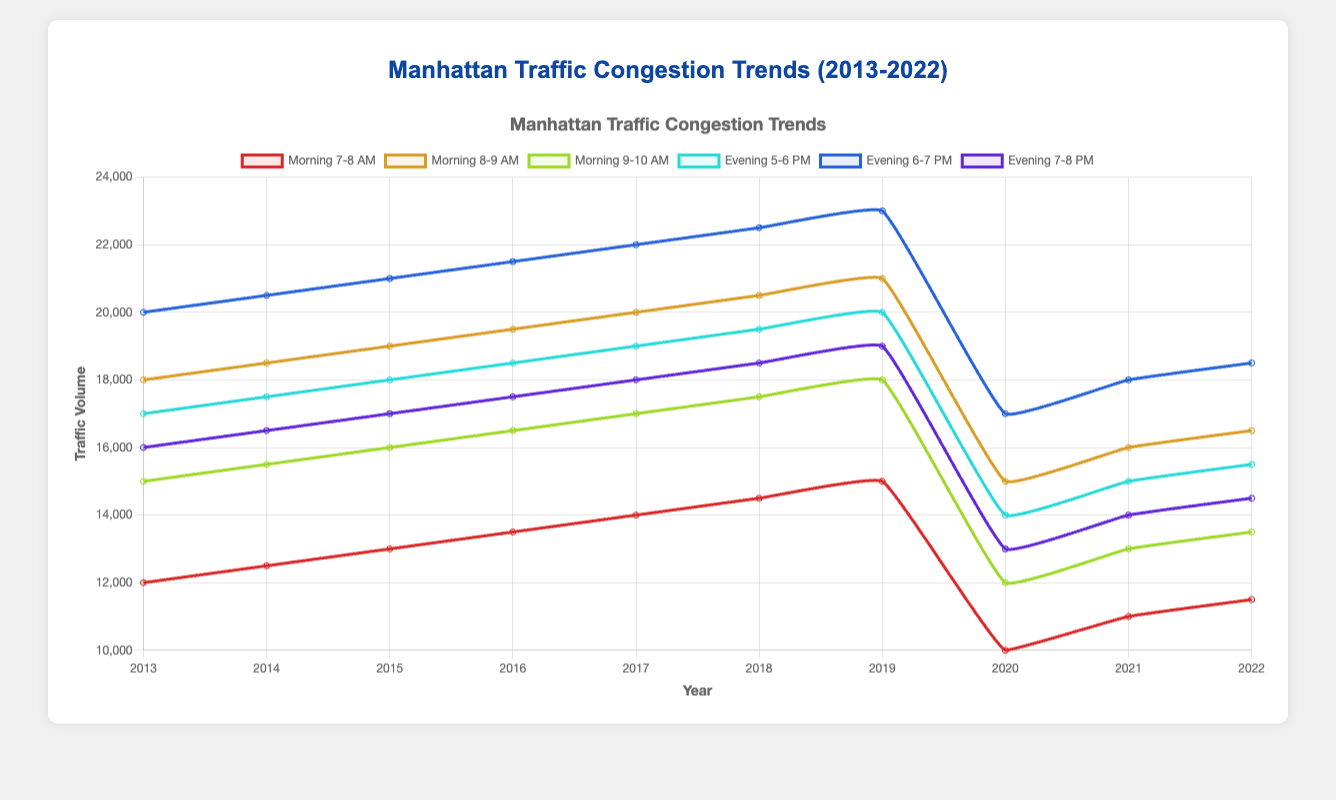What was the lowest traffic volume during evening peak hours? The lowest traffic volume during the evening peak hours can be found by comparing the traffic volumes for the three evening peak hours in each year. The lowest value is 13000 during 7-8 PM in 2020.
Answer: 13000 Which year had the highest traffic volume in the morning peak hour 8-9 AM? To find the highest traffic volume during the morning peak hour 8-9 AM, look at the values across each year for that specific hour. The highest value is 21000 in 2019.
Answer: 2019 Which peak hour was most impacted by the pandemic in 2020 in terms of traffic volume decrease compared to 2019? To determine the most impacted peak hour, calculate the difference in traffic volume for each peak hour from 2019 to 2020. The morning peak hour 9-10 AM had the largest decrease from 18000 in 2019 to 12000 in 2020, a difference of 6000.
Answer: 9-10 AM What is the overall trend in traffic volume from 2013 to 2022 for the morning peak hour 7-8 AM? The overall trend can be understood by comparing the volumes in 2013 and 2022 for the 7-8 AM hour. Traffic increased from 12000 in 2013 to 11500 in 2022, showing a slight decrease, though there appears to be an increasing trend towards 2019 before the pandemic.
Answer: Slight decrease, generally an upward trend till 2019 Which peak hour had the highest traffic volume in 2018? Look at the traffic volumes for each peak hour in 2018. The highest value is 22500 during 6-7 PM.
Answer: 6-7 PM During which year did the 7-8 PM evening peak hour have the least traffic volume? Check the traffic volumes for the 7-8 PM peak hour across all years. The lowest value is 13000 in 2020.
Answer: 2020 Calculate the average traffic volume for the 5-6 PM peak hour from 2013 to 2022. Sum the traffic volumes for each year during 5-6 PM and divide by the number of years: (17000 + 17500 + 18000 + 18500 + 19000 + 19500 + 20000 + 14000 + 15000 + 15500) / 10 = 174000 / 10 = 17400.
Answer: 17400 Compare the traffic volume trend between 2013 and 2022 for the morning 8-9 AM hour and evening 6-7 PM hour. For 8-9 AM, traffic volume rose from 18000 to 16500, while for 6-7 PM, it rose from 20000 to 18500. Both saw an increase up to 2019, followed by a decline post-pandemic but remained higher than 2013 levels.
Answer: Both increased then declined post-2019 Is the traffic volume higher in the morning or evening peak hours across all years? Compare the traffic volumes between morning peak hours (7-10 AM) and evening peak hours (5-8 PM) across all years. Generally, evening peak hours consistently have higher traffic volumes compared to morning peak hours.
Answer: Evening peak hours 